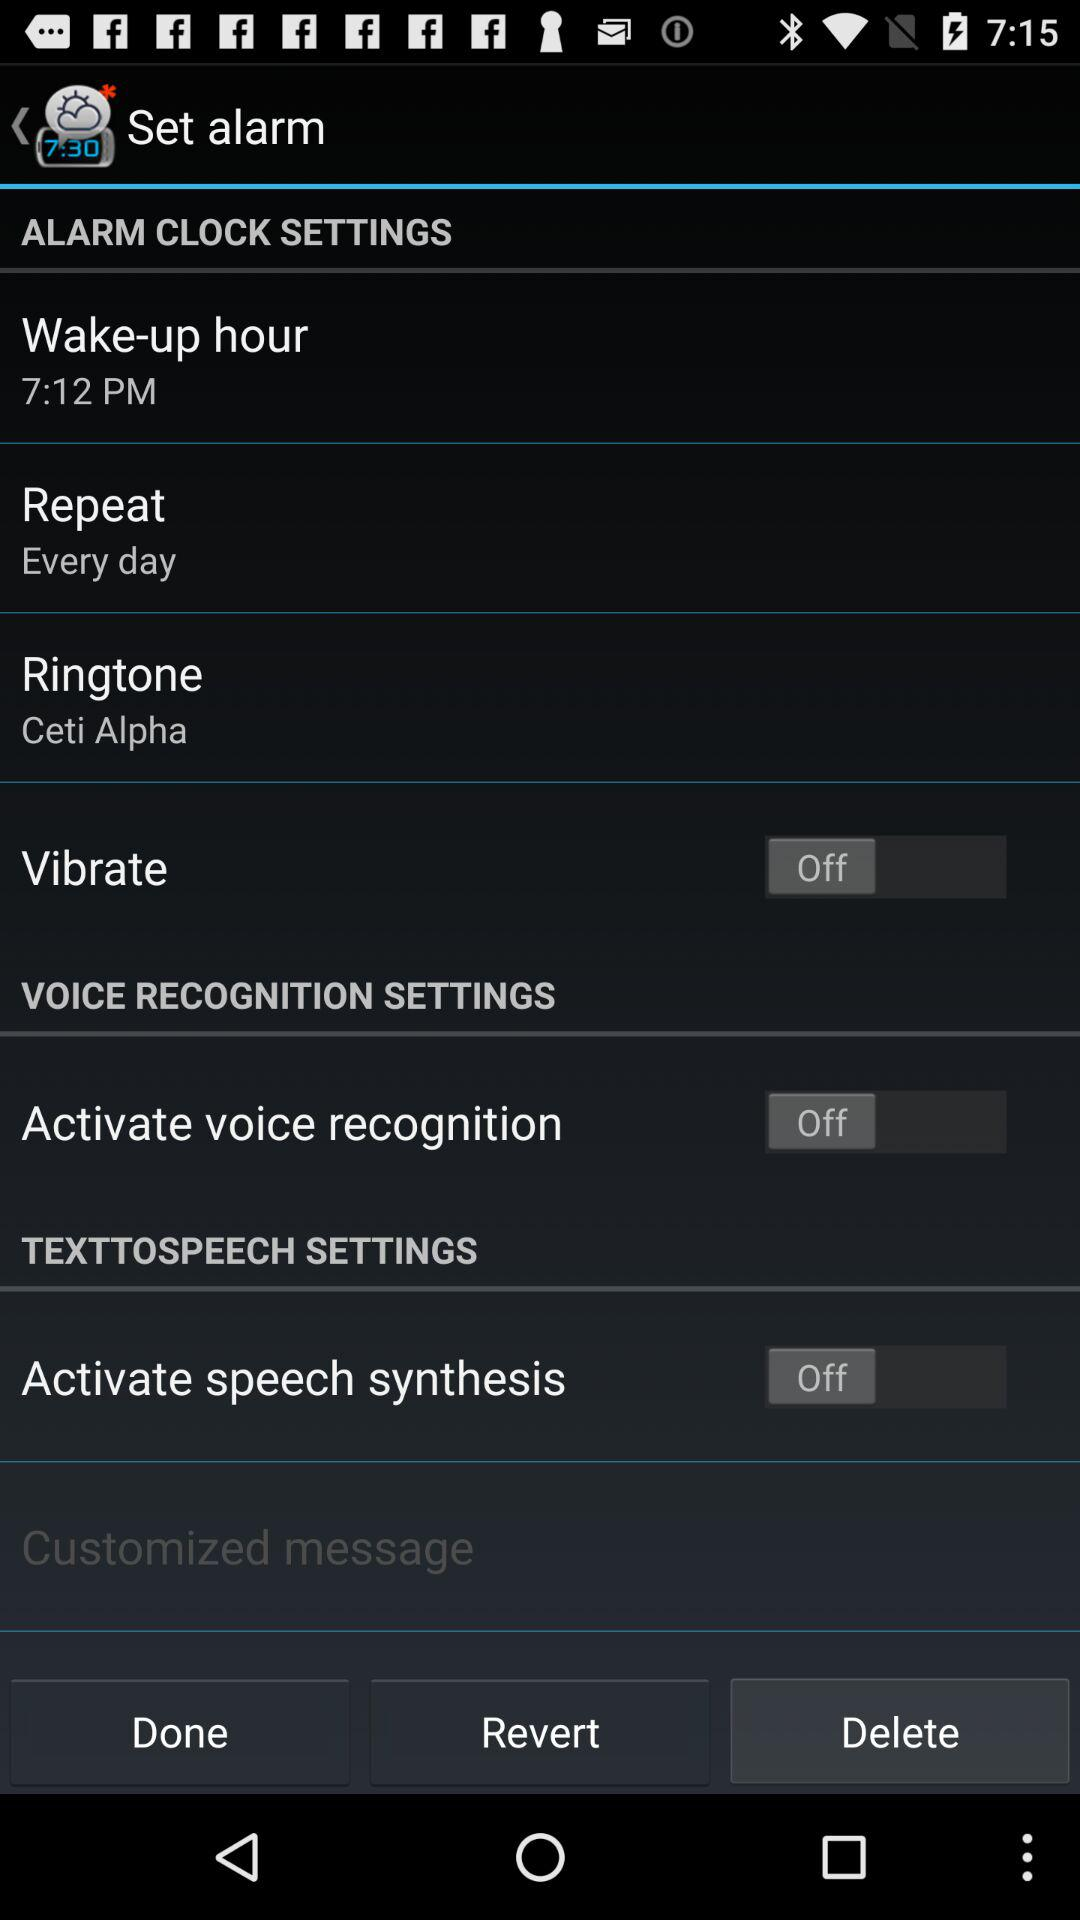Who is the customized message to?
When the provided information is insufficient, respond with <no answer>. <no answer> 